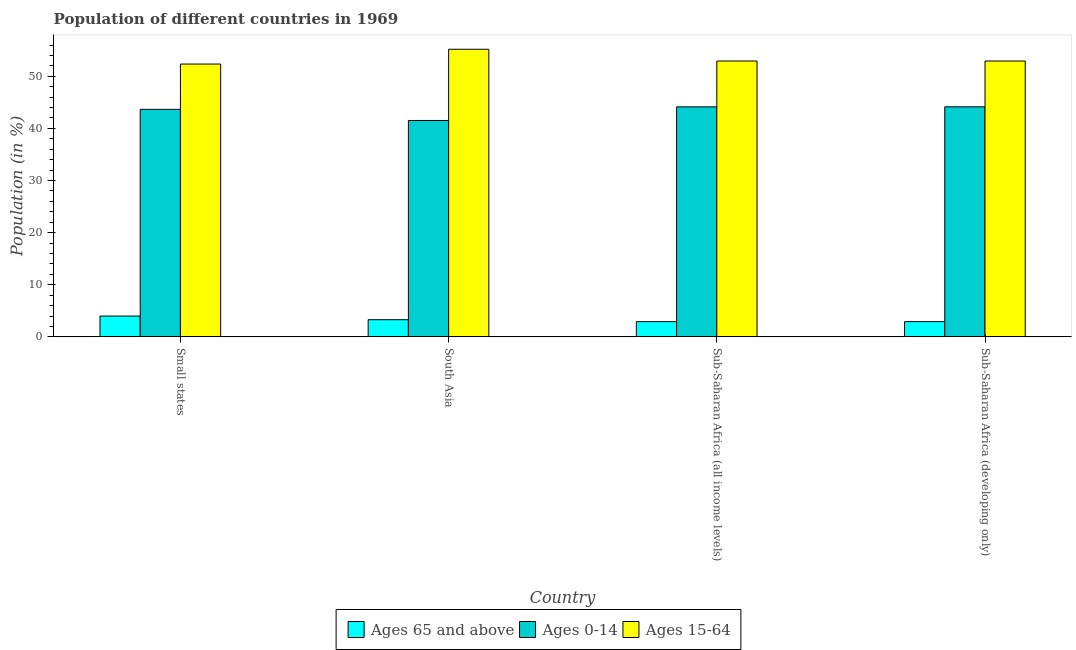How many different coloured bars are there?
Make the answer very short. 3. Are the number of bars per tick equal to the number of legend labels?
Offer a very short reply. Yes. Are the number of bars on each tick of the X-axis equal?
Your answer should be compact. Yes. How many bars are there on the 2nd tick from the right?
Provide a succinct answer. 3. What is the label of the 2nd group of bars from the left?
Keep it short and to the point. South Asia. What is the percentage of population within the age-group of 65 and above in Small states?
Ensure brevity in your answer.  3.99. Across all countries, what is the maximum percentage of population within the age-group 15-64?
Provide a succinct answer. 55.19. Across all countries, what is the minimum percentage of population within the age-group 0-14?
Provide a short and direct response. 41.52. In which country was the percentage of population within the age-group 0-14 maximum?
Offer a terse response. Sub-Saharan Africa (developing only). What is the total percentage of population within the age-group of 65 and above in the graph?
Provide a succinct answer. 13.14. What is the difference between the percentage of population within the age-group 15-64 in Small states and that in South Asia?
Offer a terse response. -2.84. What is the difference between the percentage of population within the age-group 0-14 in Sub-Saharan Africa (developing only) and the percentage of population within the age-group 15-64 in South Asia?
Provide a short and direct response. -11.04. What is the average percentage of population within the age-group 0-14 per country?
Offer a terse response. 43.36. What is the difference between the percentage of population within the age-group 0-14 and percentage of population within the age-group of 65 and above in Sub-Saharan Africa (all income levels)?
Ensure brevity in your answer.  41.21. What is the ratio of the percentage of population within the age-group 15-64 in Small states to that in Sub-Saharan Africa (developing only)?
Ensure brevity in your answer.  0.99. Is the difference between the percentage of population within the age-group of 65 and above in Sub-Saharan Africa (all income levels) and Sub-Saharan Africa (developing only) greater than the difference between the percentage of population within the age-group 0-14 in Sub-Saharan Africa (all income levels) and Sub-Saharan Africa (developing only)?
Provide a short and direct response. Yes. What is the difference between the highest and the second highest percentage of population within the age-group of 65 and above?
Make the answer very short. 0.7. What is the difference between the highest and the lowest percentage of population within the age-group 15-64?
Your answer should be compact. 2.84. What does the 3rd bar from the left in Sub-Saharan Africa (developing only) represents?
Offer a terse response. Ages 15-64. What does the 1st bar from the right in South Asia represents?
Give a very brief answer. Ages 15-64. How many bars are there?
Make the answer very short. 12. Are all the bars in the graph horizontal?
Ensure brevity in your answer.  No. What is the difference between two consecutive major ticks on the Y-axis?
Your answer should be very brief. 10. Are the values on the major ticks of Y-axis written in scientific E-notation?
Provide a succinct answer. No. Does the graph contain any zero values?
Offer a very short reply. No. Does the graph contain grids?
Your response must be concise. No. Where does the legend appear in the graph?
Provide a succinct answer. Bottom center. What is the title of the graph?
Provide a short and direct response. Population of different countries in 1969. Does "Private sector" appear as one of the legend labels in the graph?
Your answer should be compact. No. What is the label or title of the X-axis?
Keep it short and to the point. Country. What is the Population (in %) of Ages 65 and above in Small states?
Give a very brief answer. 3.99. What is the Population (in %) of Ages 0-14 in Small states?
Provide a succinct answer. 43.66. What is the Population (in %) of Ages 15-64 in Small states?
Your answer should be very brief. 52.35. What is the Population (in %) of Ages 65 and above in South Asia?
Your response must be concise. 3.29. What is the Population (in %) of Ages 0-14 in South Asia?
Your response must be concise. 41.52. What is the Population (in %) in Ages 15-64 in South Asia?
Provide a succinct answer. 55.19. What is the Population (in %) of Ages 65 and above in Sub-Saharan Africa (all income levels)?
Offer a terse response. 2.93. What is the Population (in %) in Ages 0-14 in Sub-Saharan Africa (all income levels)?
Provide a succinct answer. 44.14. What is the Population (in %) in Ages 15-64 in Sub-Saharan Africa (all income levels)?
Make the answer very short. 52.93. What is the Population (in %) in Ages 65 and above in Sub-Saharan Africa (developing only)?
Make the answer very short. 2.93. What is the Population (in %) of Ages 0-14 in Sub-Saharan Africa (developing only)?
Your answer should be very brief. 44.14. What is the Population (in %) in Ages 15-64 in Sub-Saharan Africa (developing only)?
Your answer should be very brief. 52.93. Across all countries, what is the maximum Population (in %) in Ages 65 and above?
Make the answer very short. 3.99. Across all countries, what is the maximum Population (in %) of Ages 0-14?
Ensure brevity in your answer.  44.14. Across all countries, what is the maximum Population (in %) of Ages 15-64?
Your answer should be very brief. 55.19. Across all countries, what is the minimum Population (in %) in Ages 65 and above?
Offer a very short reply. 2.93. Across all countries, what is the minimum Population (in %) of Ages 0-14?
Provide a short and direct response. 41.52. Across all countries, what is the minimum Population (in %) in Ages 15-64?
Offer a very short reply. 52.35. What is the total Population (in %) of Ages 65 and above in the graph?
Make the answer very short. 13.14. What is the total Population (in %) of Ages 0-14 in the graph?
Your answer should be compact. 173.46. What is the total Population (in %) of Ages 15-64 in the graph?
Make the answer very short. 213.4. What is the difference between the Population (in %) of Ages 65 and above in Small states and that in South Asia?
Provide a short and direct response. 0.7. What is the difference between the Population (in %) in Ages 0-14 in Small states and that in South Asia?
Offer a very short reply. 2.14. What is the difference between the Population (in %) in Ages 15-64 in Small states and that in South Asia?
Your answer should be very brief. -2.84. What is the difference between the Population (in %) of Ages 65 and above in Small states and that in Sub-Saharan Africa (all income levels)?
Ensure brevity in your answer.  1.07. What is the difference between the Population (in %) in Ages 0-14 in Small states and that in Sub-Saharan Africa (all income levels)?
Provide a succinct answer. -0.48. What is the difference between the Population (in %) in Ages 15-64 in Small states and that in Sub-Saharan Africa (all income levels)?
Your answer should be compact. -0.58. What is the difference between the Population (in %) in Ages 65 and above in Small states and that in Sub-Saharan Africa (developing only)?
Your answer should be very brief. 1.07. What is the difference between the Population (in %) of Ages 0-14 in Small states and that in Sub-Saharan Africa (developing only)?
Provide a short and direct response. -0.49. What is the difference between the Population (in %) of Ages 15-64 in Small states and that in Sub-Saharan Africa (developing only)?
Your answer should be compact. -0.58. What is the difference between the Population (in %) in Ages 65 and above in South Asia and that in Sub-Saharan Africa (all income levels)?
Provide a succinct answer. 0.36. What is the difference between the Population (in %) of Ages 0-14 in South Asia and that in Sub-Saharan Africa (all income levels)?
Your response must be concise. -2.62. What is the difference between the Population (in %) in Ages 15-64 in South Asia and that in Sub-Saharan Africa (all income levels)?
Offer a terse response. 2.25. What is the difference between the Population (in %) of Ages 65 and above in South Asia and that in Sub-Saharan Africa (developing only)?
Your answer should be compact. 0.37. What is the difference between the Population (in %) in Ages 0-14 in South Asia and that in Sub-Saharan Africa (developing only)?
Make the answer very short. -2.62. What is the difference between the Population (in %) of Ages 15-64 in South Asia and that in Sub-Saharan Africa (developing only)?
Ensure brevity in your answer.  2.26. What is the difference between the Population (in %) in Ages 65 and above in Sub-Saharan Africa (all income levels) and that in Sub-Saharan Africa (developing only)?
Offer a very short reply. 0. What is the difference between the Population (in %) of Ages 0-14 in Sub-Saharan Africa (all income levels) and that in Sub-Saharan Africa (developing only)?
Your response must be concise. -0.01. What is the difference between the Population (in %) in Ages 15-64 in Sub-Saharan Africa (all income levels) and that in Sub-Saharan Africa (developing only)?
Offer a very short reply. 0. What is the difference between the Population (in %) of Ages 65 and above in Small states and the Population (in %) of Ages 0-14 in South Asia?
Offer a very short reply. -37.53. What is the difference between the Population (in %) in Ages 65 and above in Small states and the Population (in %) in Ages 15-64 in South Asia?
Keep it short and to the point. -51.2. What is the difference between the Population (in %) in Ages 0-14 in Small states and the Population (in %) in Ages 15-64 in South Asia?
Offer a terse response. -11.53. What is the difference between the Population (in %) of Ages 65 and above in Small states and the Population (in %) of Ages 0-14 in Sub-Saharan Africa (all income levels)?
Offer a very short reply. -40.14. What is the difference between the Population (in %) of Ages 65 and above in Small states and the Population (in %) of Ages 15-64 in Sub-Saharan Africa (all income levels)?
Make the answer very short. -48.94. What is the difference between the Population (in %) in Ages 0-14 in Small states and the Population (in %) in Ages 15-64 in Sub-Saharan Africa (all income levels)?
Give a very brief answer. -9.28. What is the difference between the Population (in %) in Ages 65 and above in Small states and the Population (in %) in Ages 0-14 in Sub-Saharan Africa (developing only)?
Your answer should be very brief. -40.15. What is the difference between the Population (in %) in Ages 65 and above in Small states and the Population (in %) in Ages 15-64 in Sub-Saharan Africa (developing only)?
Keep it short and to the point. -48.94. What is the difference between the Population (in %) of Ages 0-14 in Small states and the Population (in %) of Ages 15-64 in Sub-Saharan Africa (developing only)?
Your response must be concise. -9.27. What is the difference between the Population (in %) in Ages 65 and above in South Asia and the Population (in %) in Ages 0-14 in Sub-Saharan Africa (all income levels)?
Offer a very short reply. -40.85. What is the difference between the Population (in %) in Ages 65 and above in South Asia and the Population (in %) in Ages 15-64 in Sub-Saharan Africa (all income levels)?
Your answer should be very brief. -49.64. What is the difference between the Population (in %) of Ages 0-14 in South Asia and the Population (in %) of Ages 15-64 in Sub-Saharan Africa (all income levels)?
Make the answer very short. -11.41. What is the difference between the Population (in %) in Ages 65 and above in South Asia and the Population (in %) in Ages 0-14 in Sub-Saharan Africa (developing only)?
Your answer should be compact. -40.85. What is the difference between the Population (in %) of Ages 65 and above in South Asia and the Population (in %) of Ages 15-64 in Sub-Saharan Africa (developing only)?
Your response must be concise. -49.64. What is the difference between the Population (in %) of Ages 0-14 in South Asia and the Population (in %) of Ages 15-64 in Sub-Saharan Africa (developing only)?
Provide a short and direct response. -11.41. What is the difference between the Population (in %) in Ages 65 and above in Sub-Saharan Africa (all income levels) and the Population (in %) in Ages 0-14 in Sub-Saharan Africa (developing only)?
Keep it short and to the point. -41.22. What is the difference between the Population (in %) of Ages 65 and above in Sub-Saharan Africa (all income levels) and the Population (in %) of Ages 15-64 in Sub-Saharan Africa (developing only)?
Your answer should be very brief. -50. What is the difference between the Population (in %) in Ages 0-14 in Sub-Saharan Africa (all income levels) and the Population (in %) in Ages 15-64 in Sub-Saharan Africa (developing only)?
Your response must be concise. -8.79. What is the average Population (in %) in Ages 65 and above per country?
Your answer should be very brief. 3.28. What is the average Population (in %) in Ages 0-14 per country?
Provide a short and direct response. 43.36. What is the average Population (in %) of Ages 15-64 per country?
Provide a succinct answer. 53.35. What is the difference between the Population (in %) in Ages 65 and above and Population (in %) in Ages 0-14 in Small states?
Your answer should be compact. -39.66. What is the difference between the Population (in %) in Ages 65 and above and Population (in %) in Ages 15-64 in Small states?
Offer a very short reply. -48.36. What is the difference between the Population (in %) of Ages 0-14 and Population (in %) of Ages 15-64 in Small states?
Offer a very short reply. -8.69. What is the difference between the Population (in %) of Ages 65 and above and Population (in %) of Ages 0-14 in South Asia?
Provide a short and direct response. -38.23. What is the difference between the Population (in %) of Ages 65 and above and Population (in %) of Ages 15-64 in South Asia?
Ensure brevity in your answer.  -51.9. What is the difference between the Population (in %) in Ages 0-14 and Population (in %) in Ages 15-64 in South Asia?
Your answer should be very brief. -13.67. What is the difference between the Population (in %) of Ages 65 and above and Population (in %) of Ages 0-14 in Sub-Saharan Africa (all income levels)?
Provide a short and direct response. -41.21. What is the difference between the Population (in %) in Ages 65 and above and Population (in %) in Ages 15-64 in Sub-Saharan Africa (all income levels)?
Offer a very short reply. -50.01. What is the difference between the Population (in %) of Ages 0-14 and Population (in %) of Ages 15-64 in Sub-Saharan Africa (all income levels)?
Ensure brevity in your answer.  -8.8. What is the difference between the Population (in %) in Ages 65 and above and Population (in %) in Ages 0-14 in Sub-Saharan Africa (developing only)?
Provide a succinct answer. -41.22. What is the difference between the Population (in %) in Ages 65 and above and Population (in %) in Ages 15-64 in Sub-Saharan Africa (developing only)?
Provide a short and direct response. -50.01. What is the difference between the Population (in %) of Ages 0-14 and Population (in %) of Ages 15-64 in Sub-Saharan Africa (developing only)?
Provide a succinct answer. -8.79. What is the ratio of the Population (in %) in Ages 65 and above in Small states to that in South Asia?
Keep it short and to the point. 1.21. What is the ratio of the Population (in %) in Ages 0-14 in Small states to that in South Asia?
Offer a terse response. 1.05. What is the ratio of the Population (in %) in Ages 15-64 in Small states to that in South Asia?
Make the answer very short. 0.95. What is the ratio of the Population (in %) of Ages 65 and above in Small states to that in Sub-Saharan Africa (all income levels)?
Provide a succinct answer. 1.36. What is the ratio of the Population (in %) of Ages 15-64 in Small states to that in Sub-Saharan Africa (all income levels)?
Your response must be concise. 0.99. What is the ratio of the Population (in %) in Ages 65 and above in Small states to that in Sub-Saharan Africa (developing only)?
Offer a terse response. 1.37. What is the ratio of the Population (in %) in Ages 15-64 in Small states to that in Sub-Saharan Africa (developing only)?
Give a very brief answer. 0.99. What is the ratio of the Population (in %) in Ages 65 and above in South Asia to that in Sub-Saharan Africa (all income levels)?
Provide a short and direct response. 1.12. What is the ratio of the Population (in %) in Ages 0-14 in South Asia to that in Sub-Saharan Africa (all income levels)?
Your answer should be very brief. 0.94. What is the ratio of the Population (in %) in Ages 15-64 in South Asia to that in Sub-Saharan Africa (all income levels)?
Give a very brief answer. 1.04. What is the ratio of the Population (in %) in Ages 65 and above in South Asia to that in Sub-Saharan Africa (developing only)?
Give a very brief answer. 1.13. What is the ratio of the Population (in %) in Ages 0-14 in South Asia to that in Sub-Saharan Africa (developing only)?
Make the answer very short. 0.94. What is the ratio of the Population (in %) in Ages 15-64 in South Asia to that in Sub-Saharan Africa (developing only)?
Your answer should be compact. 1.04. What is the ratio of the Population (in %) in Ages 0-14 in Sub-Saharan Africa (all income levels) to that in Sub-Saharan Africa (developing only)?
Keep it short and to the point. 1. What is the ratio of the Population (in %) in Ages 15-64 in Sub-Saharan Africa (all income levels) to that in Sub-Saharan Africa (developing only)?
Provide a short and direct response. 1. What is the difference between the highest and the second highest Population (in %) of Ages 65 and above?
Your answer should be compact. 0.7. What is the difference between the highest and the second highest Population (in %) of Ages 0-14?
Your answer should be compact. 0.01. What is the difference between the highest and the second highest Population (in %) in Ages 15-64?
Offer a terse response. 2.25. What is the difference between the highest and the lowest Population (in %) of Ages 65 and above?
Give a very brief answer. 1.07. What is the difference between the highest and the lowest Population (in %) in Ages 0-14?
Provide a succinct answer. 2.62. What is the difference between the highest and the lowest Population (in %) of Ages 15-64?
Offer a very short reply. 2.84. 